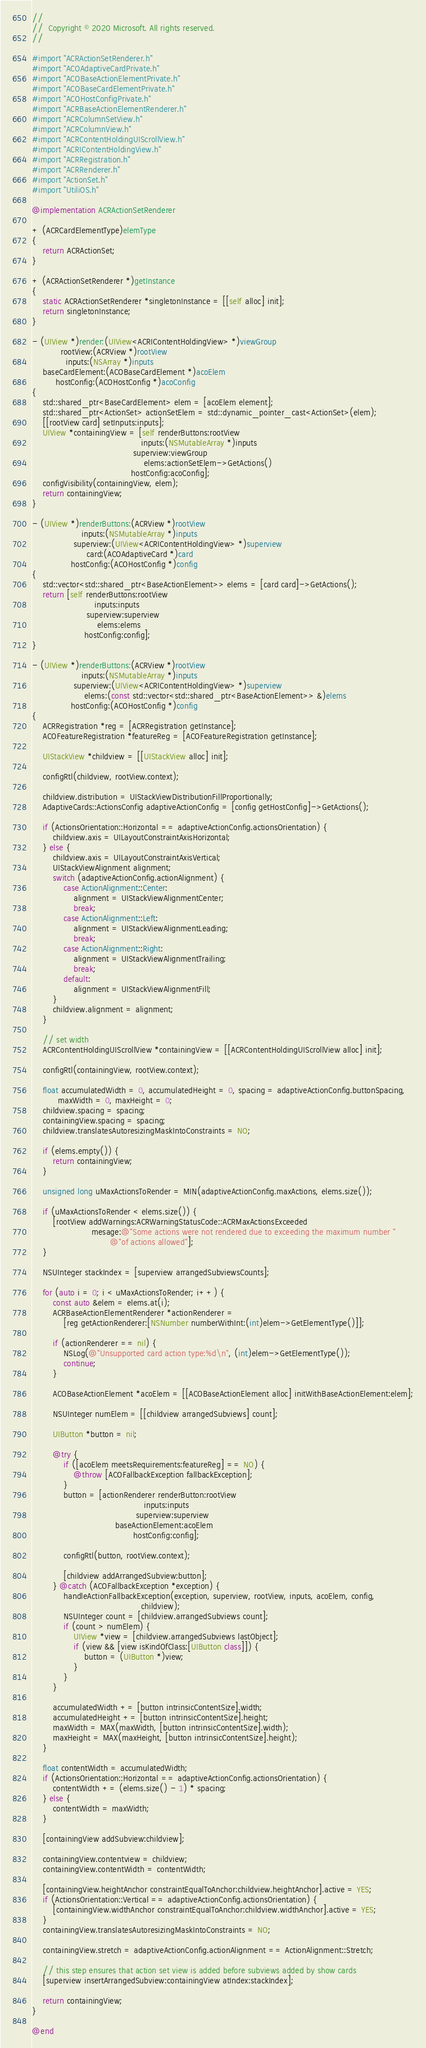Convert code to text. <code><loc_0><loc_0><loc_500><loc_500><_ObjectiveC_>//
//  Copyright © 2020 Microsoft. All rights reserved.
//

#import "ACRActionSetRenderer.h"
#import "ACOAdaptiveCardPrivate.h"
#import "ACOBaseActionElementPrivate.h"
#import "ACOBaseCardElementPrivate.h"
#import "ACOHostConfigPrivate.h"
#import "ACRBaseActionElementRenderer.h"
#import "ACRColumnSetView.h"
#import "ACRColumnView.h"
#import "ACRContentHoldingUIScrollView.h"
#import "ACRIContentHoldingView.h"
#import "ACRRegistration.h"
#import "ACRRenderer.h"
#import "ActionSet.h"
#import "UtiliOS.h"

@implementation ACRActionSetRenderer

+ (ACRCardElementType)elemType
{
    return ACRActionSet;
}

+ (ACRActionSetRenderer *)getInstance
{
    static ACRActionSetRenderer *singletonInstance = [[self alloc] init];
    return singletonInstance;
}

- (UIView *)render:(UIView<ACRIContentHoldingView> *)viewGroup
           rootView:(ACRView *)rootView
             inputs:(NSArray *)inputs
    baseCardElement:(ACOBaseCardElement *)acoElem
         hostConfig:(ACOHostConfig *)acoConfig
{
    std::shared_ptr<BaseCardElement> elem = [acoElem element];
    std::shared_ptr<ActionSet> actionSetElem = std::dynamic_pointer_cast<ActionSet>(elem);
    [[rootView card] setInputs:inputs];
    UIView *containingView = [self renderButtons:rootView
                                          inputs:(NSMutableArray *)inputs
                                       superview:viewGroup
                                           elems:actionSetElem->GetActions()
                                      hostConfig:acoConfig];
    configVisibility(containingView, elem);
    return containingView;
}

- (UIView *)renderButtons:(ACRView *)rootView
                   inputs:(NSMutableArray *)inputs
                superview:(UIView<ACRIContentHoldingView> *)superview
                     card:(ACOAdaptiveCard *)card
               hostConfig:(ACOHostConfig *)config
{
    std::vector<std::shared_ptr<BaseActionElement>> elems = [card card]->GetActions();
    return [self renderButtons:rootView
                        inputs:inputs
                     superview:superview
                         elems:elems
                    hostConfig:config];
}

- (UIView *)renderButtons:(ACRView *)rootView
                   inputs:(NSMutableArray *)inputs
                superview:(UIView<ACRIContentHoldingView> *)superview
                    elems:(const std::vector<std::shared_ptr<BaseActionElement>> &)elems
               hostConfig:(ACOHostConfig *)config
{
    ACRRegistration *reg = [ACRRegistration getInstance];
    ACOFeatureRegistration *featureReg = [ACOFeatureRegistration getInstance];

    UIStackView *childview = [[UIStackView alloc] init];

    configRtl(childview, rootView.context);

    childview.distribution = UIStackViewDistributionFillProportionally;
    AdaptiveCards::ActionsConfig adaptiveActionConfig = [config getHostConfig]->GetActions();

    if (ActionsOrientation::Horizontal == adaptiveActionConfig.actionsOrientation) {
        childview.axis = UILayoutConstraintAxisHorizontal;
    } else {
        childview.axis = UILayoutConstraintAxisVertical;
        UIStackViewAlignment alignment;
        switch (adaptiveActionConfig.actionAlignment) {
            case ActionAlignment::Center:
                alignment = UIStackViewAlignmentCenter;
                break;
            case ActionAlignment::Left:
                alignment = UIStackViewAlignmentLeading;
                break;
            case ActionAlignment::Right:
                alignment = UIStackViewAlignmentTrailing;
                break;
            default:
                alignment = UIStackViewAlignmentFill;
        }
        childview.alignment = alignment;
    }

    // set width
    ACRContentHoldingUIScrollView *containingView = [[ACRContentHoldingUIScrollView alloc] init];

    configRtl(containingView, rootView.context);

    float accumulatedWidth = 0, accumulatedHeight = 0, spacing = adaptiveActionConfig.buttonSpacing,
          maxWidth = 0, maxHeight = 0;
    childview.spacing = spacing;
    containingView.spacing = spacing;
    childview.translatesAutoresizingMaskIntoConstraints = NO;

    if (elems.empty()) {
        return containingView;
    }

    unsigned long uMaxActionsToRender = MIN(adaptiveActionConfig.maxActions, elems.size());

    if (uMaxActionsToRender < elems.size()) {
        [rootView addWarnings:ACRWarningStatusCode::ACRMaxActionsExceeded
                       mesage:@"Some actions were not rendered due to exceeding the maximum number "
                              @"of actions allowed"];
    }

    NSUInteger stackIndex = [superview arrangedSubviewsCounts];

    for (auto i = 0; i < uMaxActionsToRender; i++) {
        const auto &elem = elems.at(i);
        ACRBaseActionElementRenderer *actionRenderer =
            [reg getActionRenderer:[NSNumber numberWithInt:(int)elem->GetElementType()]];

        if (actionRenderer == nil) {
            NSLog(@"Unsupported card action type:%d\n", (int)elem->GetElementType());
            continue;
        }

        ACOBaseActionElement *acoElem = [[ACOBaseActionElement alloc] initWithBaseActionElement:elem];

        NSUInteger numElem = [[childview arrangedSubviews] count];

        UIButton *button = nil;

        @try {
            if ([acoElem meetsRequirements:featureReg] == NO) {
                @throw [ACOFallbackException fallbackException];
            }
            button = [actionRenderer renderButton:rootView
                                           inputs:inputs
                                        superview:superview
                                baseActionElement:acoElem
                                       hostConfig:config];

            configRtl(button, rootView.context);

            [childview addArrangedSubview:button];
        } @catch (ACOFallbackException *exception) {
            handleActionFallbackException(exception, superview, rootView, inputs, acoElem, config,
                                          childview);
            NSUInteger count = [childview.arrangedSubviews count];
            if (count > numElem) {
                UIView *view = [childview.arrangedSubviews lastObject];
                if (view && [view isKindOfClass:[UIButton class]]) {
                    button = (UIButton *)view;
                }
            }
        }

        accumulatedWidth += [button intrinsicContentSize].width;
        accumulatedHeight += [button intrinsicContentSize].height;
        maxWidth = MAX(maxWidth, [button intrinsicContentSize].width);
        maxHeight = MAX(maxHeight, [button intrinsicContentSize].height);
    }

    float contentWidth = accumulatedWidth;
    if (ActionsOrientation::Horizontal == adaptiveActionConfig.actionsOrientation) {
        contentWidth += (elems.size() - 1) * spacing;
    } else {
        contentWidth = maxWidth;
    }

    [containingView addSubview:childview];

    containingView.contentview = childview;
    containingView.contentWidth = contentWidth;

    [containingView.heightAnchor constraintEqualToAnchor:childview.heightAnchor].active = YES;
    if (ActionsOrientation::Vertical == adaptiveActionConfig.actionsOrientation) {
        [containingView.widthAnchor constraintEqualToAnchor:childview.widthAnchor].active = YES;
    }
    containingView.translatesAutoresizingMaskIntoConstraints = NO;

    containingView.stretch = adaptiveActionConfig.actionAlignment == ActionAlignment::Stretch;

    // this step ensures that action set view is added before subviews added by show cards
    [superview insertArrangedSubview:containingView atIndex:stackIndex];

    return containingView;
}

@end
</code> 